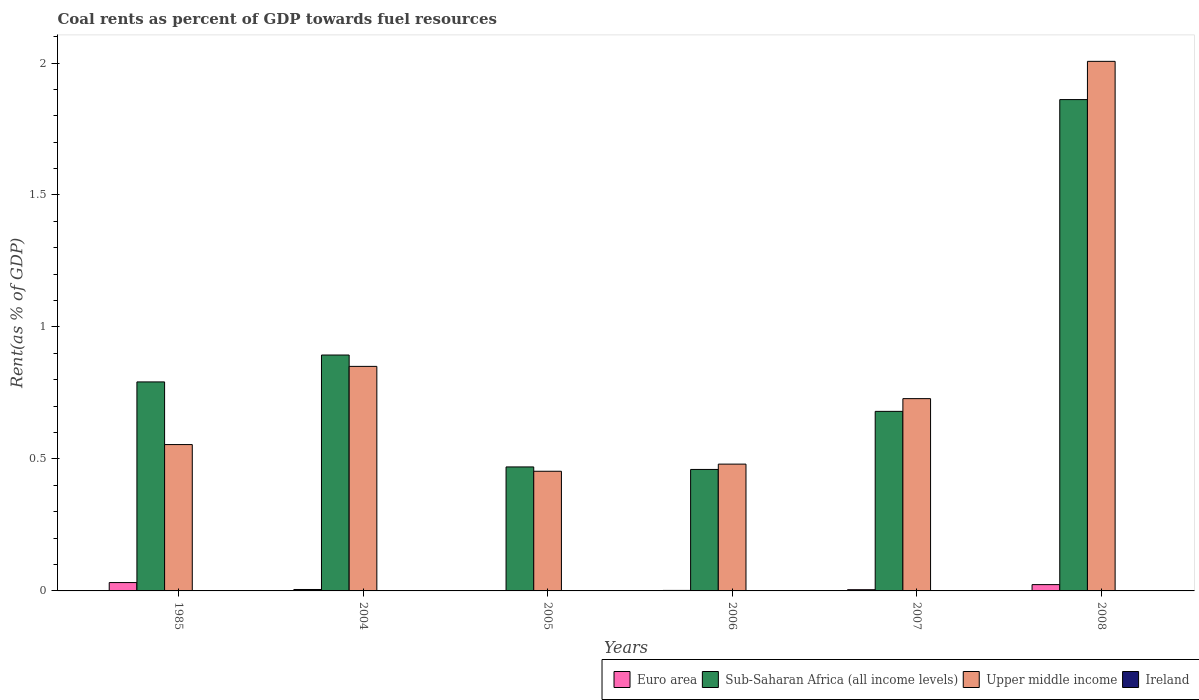Are the number of bars on each tick of the X-axis equal?
Your response must be concise. Yes. What is the label of the 1st group of bars from the left?
Your answer should be compact. 1985. What is the coal rent in Upper middle income in 2006?
Ensure brevity in your answer.  0.48. Across all years, what is the maximum coal rent in Euro area?
Your answer should be compact. 0.03. Across all years, what is the minimum coal rent in Ireland?
Give a very brief answer. 7.66717495498807e-5. In which year was the coal rent in Euro area maximum?
Keep it short and to the point. 1985. In which year was the coal rent in Ireland minimum?
Provide a short and direct response. 2005. What is the total coal rent in Ireland in the graph?
Give a very brief answer. 0. What is the difference between the coal rent in Sub-Saharan Africa (all income levels) in 2005 and that in 2008?
Your response must be concise. -1.39. What is the difference between the coal rent in Ireland in 2005 and the coal rent in Sub-Saharan Africa (all income levels) in 2006?
Ensure brevity in your answer.  -0.46. What is the average coal rent in Euro area per year?
Provide a succinct answer. 0.01. In the year 1985, what is the difference between the coal rent in Ireland and coal rent in Euro area?
Make the answer very short. -0.03. What is the ratio of the coal rent in Euro area in 2007 to that in 2008?
Your response must be concise. 0.2. Is the coal rent in Euro area in 2007 less than that in 2008?
Give a very brief answer. Yes. Is the difference between the coal rent in Ireland in 2004 and 2007 greater than the difference between the coal rent in Euro area in 2004 and 2007?
Your answer should be compact. No. What is the difference between the highest and the second highest coal rent in Sub-Saharan Africa (all income levels)?
Your answer should be compact. 0.97. What is the difference between the highest and the lowest coal rent in Ireland?
Offer a terse response. 0. Is it the case that in every year, the sum of the coal rent in Sub-Saharan Africa (all income levels) and coal rent in Euro area is greater than the sum of coal rent in Upper middle income and coal rent in Ireland?
Offer a very short reply. Yes. What does the 4th bar from the left in 2007 represents?
Ensure brevity in your answer.  Ireland. What does the 2nd bar from the right in 2007 represents?
Provide a succinct answer. Upper middle income. Is it the case that in every year, the sum of the coal rent in Sub-Saharan Africa (all income levels) and coal rent in Ireland is greater than the coal rent in Upper middle income?
Your response must be concise. No. How many bars are there?
Your answer should be compact. 24. Are all the bars in the graph horizontal?
Provide a short and direct response. No. How many years are there in the graph?
Your answer should be very brief. 6. Are the values on the major ticks of Y-axis written in scientific E-notation?
Your answer should be very brief. No. Where does the legend appear in the graph?
Provide a succinct answer. Bottom right. How are the legend labels stacked?
Offer a very short reply. Horizontal. What is the title of the graph?
Offer a very short reply. Coal rents as percent of GDP towards fuel resources. What is the label or title of the Y-axis?
Keep it short and to the point. Rent(as % of GDP). What is the Rent(as % of GDP) of Euro area in 1985?
Your response must be concise. 0.03. What is the Rent(as % of GDP) of Sub-Saharan Africa (all income levels) in 1985?
Offer a very short reply. 0.79. What is the Rent(as % of GDP) in Upper middle income in 1985?
Offer a very short reply. 0.55. What is the Rent(as % of GDP) of Ireland in 1985?
Offer a terse response. 0. What is the Rent(as % of GDP) of Euro area in 2004?
Offer a very short reply. 0.01. What is the Rent(as % of GDP) of Sub-Saharan Africa (all income levels) in 2004?
Your answer should be very brief. 0.89. What is the Rent(as % of GDP) in Upper middle income in 2004?
Keep it short and to the point. 0.85. What is the Rent(as % of GDP) of Ireland in 2004?
Keep it short and to the point. 0. What is the Rent(as % of GDP) in Euro area in 2005?
Your answer should be compact. 0. What is the Rent(as % of GDP) of Sub-Saharan Africa (all income levels) in 2005?
Your answer should be compact. 0.47. What is the Rent(as % of GDP) in Upper middle income in 2005?
Your response must be concise. 0.45. What is the Rent(as % of GDP) in Ireland in 2005?
Offer a terse response. 7.66717495498807e-5. What is the Rent(as % of GDP) in Euro area in 2006?
Give a very brief answer. 0. What is the Rent(as % of GDP) of Sub-Saharan Africa (all income levels) in 2006?
Provide a short and direct response. 0.46. What is the Rent(as % of GDP) in Upper middle income in 2006?
Offer a very short reply. 0.48. What is the Rent(as % of GDP) in Ireland in 2006?
Your response must be concise. 0. What is the Rent(as % of GDP) in Euro area in 2007?
Provide a short and direct response. 0. What is the Rent(as % of GDP) of Sub-Saharan Africa (all income levels) in 2007?
Provide a succinct answer. 0.68. What is the Rent(as % of GDP) in Upper middle income in 2007?
Offer a terse response. 0.73. What is the Rent(as % of GDP) of Ireland in 2007?
Provide a succinct answer. 0. What is the Rent(as % of GDP) of Euro area in 2008?
Provide a succinct answer. 0.02. What is the Rent(as % of GDP) of Sub-Saharan Africa (all income levels) in 2008?
Give a very brief answer. 1.86. What is the Rent(as % of GDP) of Upper middle income in 2008?
Keep it short and to the point. 2.01. What is the Rent(as % of GDP) in Ireland in 2008?
Provide a succinct answer. 0. Across all years, what is the maximum Rent(as % of GDP) of Euro area?
Ensure brevity in your answer.  0.03. Across all years, what is the maximum Rent(as % of GDP) in Sub-Saharan Africa (all income levels)?
Offer a terse response. 1.86. Across all years, what is the maximum Rent(as % of GDP) in Upper middle income?
Provide a succinct answer. 2.01. Across all years, what is the maximum Rent(as % of GDP) of Ireland?
Offer a terse response. 0. Across all years, what is the minimum Rent(as % of GDP) in Euro area?
Make the answer very short. 0. Across all years, what is the minimum Rent(as % of GDP) in Sub-Saharan Africa (all income levels)?
Keep it short and to the point. 0.46. Across all years, what is the minimum Rent(as % of GDP) in Upper middle income?
Keep it short and to the point. 0.45. Across all years, what is the minimum Rent(as % of GDP) of Ireland?
Keep it short and to the point. 7.66717495498807e-5. What is the total Rent(as % of GDP) of Euro area in the graph?
Keep it short and to the point. 0.07. What is the total Rent(as % of GDP) of Sub-Saharan Africa (all income levels) in the graph?
Ensure brevity in your answer.  5.16. What is the total Rent(as % of GDP) of Upper middle income in the graph?
Give a very brief answer. 5.07. What is the total Rent(as % of GDP) in Ireland in the graph?
Your answer should be compact. 0. What is the difference between the Rent(as % of GDP) in Euro area in 1985 and that in 2004?
Your answer should be compact. 0.03. What is the difference between the Rent(as % of GDP) in Sub-Saharan Africa (all income levels) in 1985 and that in 2004?
Your answer should be compact. -0.1. What is the difference between the Rent(as % of GDP) in Upper middle income in 1985 and that in 2004?
Offer a very short reply. -0.3. What is the difference between the Rent(as % of GDP) of Euro area in 1985 and that in 2005?
Your answer should be very brief. 0.03. What is the difference between the Rent(as % of GDP) in Sub-Saharan Africa (all income levels) in 1985 and that in 2005?
Offer a terse response. 0.32. What is the difference between the Rent(as % of GDP) in Upper middle income in 1985 and that in 2005?
Make the answer very short. 0.1. What is the difference between the Rent(as % of GDP) of Ireland in 1985 and that in 2005?
Your answer should be compact. 0. What is the difference between the Rent(as % of GDP) of Euro area in 1985 and that in 2006?
Make the answer very short. 0.03. What is the difference between the Rent(as % of GDP) of Sub-Saharan Africa (all income levels) in 1985 and that in 2006?
Keep it short and to the point. 0.33. What is the difference between the Rent(as % of GDP) of Upper middle income in 1985 and that in 2006?
Your response must be concise. 0.07. What is the difference between the Rent(as % of GDP) in Ireland in 1985 and that in 2006?
Offer a very short reply. 0. What is the difference between the Rent(as % of GDP) in Euro area in 1985 and that in 2007?
Give a very brief answer. 0.03. What is the difference between the Rent(as % of GDP) in Sub-Saharan Africa (all income levels) in 1985 and that in 2007?
Offer a very short reply. 0.11. What is the difference between the Rent(as % of GDP) in Upper middle income in 1985 and that in 2007?
Your response must be concise. -0.17. What is the difference between the Rent(as % of GDP) of Euro area in 1985 and that in 2008?
Your answer should be compact. 0.01. What is the difference between the Rent(as % of GDP) in Sub-Saharan Africa (all income levels) in 1985 and that in 2008?
Provide a short and direct response. -1.07. What is the difference between the Rent(as % of GDP) of Upper middle income in 1985 and that in 2008?
Make the answer very short. -1.45. What is the difference between the Rent(as % of GDP) of Ireland in 1985 and that in 2008?
Your answer should be compact. -0. What is the difference between the Rent(as % of GDP) of Euro area in 2004 and that in 2005?
Your answer should be compact. 0. What is the difference between the Rent(as % of GDP) in Sub-Saharan Africa (all income levels) in 2004 and that in 2005?
Your answer should be compact. 0.42. What is the difference between the Rent(as % of GDP) of Upper middle income in 2004 and that in 2005?
Ensure brevity in your answer.  0.4. What is the difference between the Rent(as % of GDP) of Euro area in 2004 and that in 2006?
Your answer should be compact. 0. What is the difference between the Rent(as % of GDP) in Sub-Saharan Africa (all income levels) in 2004 and that in 2006?
Your answer should be compact. 0.43. What is the difference between the Rent(as % of GDP) of Upper middle income in 2004 and that in 2006?
Offer a very short reply. 0.37. What is the difference between the Rent(as % of GDP) of Ireland in 2004 and that in 2006?
Give a very brief answer. 0. What is the difference between the Rent(as % of GDP) of Euro area in 2004 and that in 2007?
Ensure brevity in your answer.  0. What is the difference between the Rent(as % of GDP) of Sub-Saharan Africa (all income levels) in 2004 and that in 2007?
Provide a succinct answer. 0.21. What is the difference between the Rent(as % of GDP) in Upper middle income in 2004 and that in 2007?
Offer a terse response. 0.12. What is the difference between the Rent(as % of GDP) of Euro area in 2004 and that in 2008?
Give a very brief answer. -0.02. What is the difference between the Rent(as % of GDP) of Sub-Saharan Africa (all income levels) in 2004 and that in 2008?
Your answer should be compact. -0.97. What is the difference between the Rent(as % of GDP) in Upper middle income in 2004 and that in 2008?
Your answer should be very brief. -1.16. What is the difference between the Rent(as % of GDP) in Ireland in 2004 and that in 2008?
Provide a short and direct response. -0. What is the difference between the Rent(as % of GDP) in Euro area in 2005 and that in 2006?
Offer a terse response. -0. What is the difference between the Rent(as % of GDP) in Sub-Saharan Africa (all income levels) in 2005 and that in 2006?
Offer a very short reply. 0.01. What is the difference between the Rent(as % of GDP) in Upper middle income in 2005 and that in 2006?
Your answer should be very brief. -0.03. What is the difference between the Rent(as % of GDP) in Euro area in 2005 and that in 2007?
Ensure brevity in your answer.  -0. What is the difference between the Rent(as % of GDP) of Sub-Saharan Africa (all income levels) in 2005 and that in 2007?
Your answer should be very brief. -0.21. What is the difference between the Rent(as % of GDP) in Upper middle income in 2005 and that in 2007?
Ensure brevity in your answer.  -0.28. What is the difference between the Rent(as % of GDP) in Ireland in 2005 and that in 2007?
Keep it short and to the point. -0. What is the difference between the Rent(as % of GDP) of Euro area in 2005 and that in 2008?
Offer a very short reply. -0.02. What is the difference between the Rent(as % of GDP) of Sub-Saharan Africa (all income levels) in 2005 and that in 2008?
Offer a very short reply. -1.39. What is the difference between the Rent(as % of GDP) in Upper middle income in 2005 and that in 2008?
Provide a succinct answer. -1.55. What is the difference between the Rent(as % of GDP) in Ireland in 2005 and that in 2008?
Ensure brevity in your answer.  -0. What is the difference between the Rent(as % of GDP) in Euro area in 2006 and that in 2007?
Your answer should be compact. -0. What is the difference between the Rent(as % of GDP) in Sub-Saharan Africa (all income levels) in 2006 and that in 2007?
Give a very brief answer. -0.22. What is the difference between the Rent(as % of GDP) of Upper middle income in 2006 and that in 2007?
Your response must be concise. -0.25. What is the difference between the Rent(as % of GDP) of Ireland in 2006 and that in 2007?
Your answer should be very brief. -0. What is the difference between the Rent(as % of GDP) in Euro area in 2006 and that in 2008?
Offer a very short reply. -0.02. What is the difference between the Rent(as % of GDP) in Sub-Saharan Africa (all income levels) in 2006 and that in 2008?
Your answer should be compact. -1.4. What is the difference between the Rent(as % of GDP) in Upper middle income in 2006 and that in 2008?
Your response must be concise. -1.53. What is the difference between the Rent(as % of GDP) in Ireland in 2006 and that in 2008?
Ensure brevity in your answer.  -0. What is the difference between the Rent(as % of GDP) in Euro area in 2007 and that in 2008?
Make the answer very short. -0.02. What is the difference between the Rent(as % of GDP) in Sub-Saharan Africa (all income levels) in 2007 and that in 2008?
Give a very brief answer. -1.18. What is the difference between the Rent(as % of GDP) in Upper middle income in 2007 and that in 2008?
Give a very brief answer. -1.28. What is the difference between the Rent(as % of GDP) in Ireland in 2007 and that in 2008?
Your answer should be very brief. -0. What is the difference between the Rent(as % of GDP) in Euro area in 1985 and the Rent(as % of GDP) in Sub-Saharan Africa (all income levels) in 2004?
Your answer should be very brief. -0.86. What is the difference between the Rent(as % of GDP) in Euro area in 1985 and the Rent(as % of GDP) in Upper middle income in 2004?
Your answer should be very brief. -0.82. What is the difference between the Rent(as % of GDP) in Euro area in 1985 and the Rent(as % of GDP) in Ireland in 2004?
Your answer should be compact. 0.03. What is the difference between the Rent(as % of GDP) in Sub-Saharan Africa (all income levels) in 1985 and the Rent(as % of GDP) in Upper middle income in 2004?
Your answer should be very brief. -0.06. What is the difference between the Rent(as % of GDP) of Sub-Saharan Africa (all income levels) in 1985 and the Rent(as % of GDP) of Ireland in 2004?
Ensure brevity in your answer.  0.79. What is the difference between the Rent(as % of GDP) in Upper middle income in 1985 and the Rent(as % of GDP) in Ireland in 2004?
Your answer should be very brief. 0.55. What is the difference between the Rent(as % of GDP) in Euro area in 1985 and the Rent(as % of GDP) in Sub-Saharan Africa (all income levels) in 2005?
Your answer should be compact. -0.44. What is the difference between the Rent(as % of GDP) of Euro area in 1985 and the Rent(as % of GDP) of Upper middle income in 2005?
Offer a terse response. -0.42. What is the difference between the Rent(as % of GDP) in Euro area in 1985 and the Rent(as % of GDP) in Ireland in 2005?
Offer a very short reply. 0.03. What is the difference between the Rent(as % of GDP) in Sub-Saharan Africa (all income levels) in 1985 and the Rent(as % of GDP) in Upper middle income in 2005?
Your response must be concise. 0.34. What is the difference between the Rent(as % of GDP) of Sub-Saharan Africa (all income levels) in 1985 and the Rent(as % of GDP) of Ireland in 2005?
Provide a succinct answer. 0.79. What is the difference between the Rent(as % of GDP) of Upper middle income in 1985 and the Rent(as % of GDP) of Ireland in 2005?
Make the answer very short. 0.55. What is the difference between the Rent(as % of GDP) of Euro area in 1985 and the Rent(as % of GDP) of Sub-Saharan Africa (all income levels) in 2006?
Keep it short and to the point. -0.43. What is the difference between the Rent(as % of GDP) of Euro area in 1985 and the Rent(as % of GDP) of Upper middle income in 2006?
Ensure brevity in your answer.  -0.45. What is the difference between the Rent(as % of GDP) of Euro area in 1985 and the Rent(as % of GDP) of Ireland in 2006?
Make the answer very short. 0.03. What is the difference between the Rent(as % of GDP) in Sub-Saharan Africa (all income levels) in 1985 and the Rent(as % of GDP) in Upper middle income in 2006?
Your response must be concise. 0.31. What is the difference between the Rent(as % of GDP) in Sub-Saharan Africa (all income levels) in 1985 and the Rent(as % of GDP) in Ireland in 2006?
Offer a terse response. 0.79. What is the difference between the Rent(as % of GDP) in Upper middle income in 1985 and the Rent(as % of GDP) in Ireland in 2006?
Offer a very short reply. 0.55. What is the difference between the Rent(as % of GDP) in Euro area in 1985 and the Rent(as % of GDP) in Sub-Saharan Africa (all income levels) in 2007?
Your answer should be very brief. -0.65. What is the difference between the Rent(as % of GDP) in Euro area in 1985 and the Rent(as % of GDP) in Upper middle income in 2007?
Give a very brief answer. -0.7. What is the difference between the Rent(as % of GDP) of Euro area in 1985 and the Rent(as % of GDP) of Ireland in 2007?
Offer a terse response. 0.03. What is the difference between the Rent(as % of GDP) in Sub-Saharan Africa (all income levels) in 1985 and the Rent(as % of GDP) in Upper middle income in 2007?
Offer a very short reply. 0.06. What is the difference between the Rent(as % of GDP) in Sub-Saharan Africa (all income levels) in 1985 and the Rent(as % of GDP) in Ireland in 2007?
Make the answer very short. 0.79. What is the difference between the Rent(as % of GDP) in Upper middle income in 1985 and the Rent(as % of GDP) in Ireland in 2007?
Give a very brief answer. 0.55. What is the difference between the Rent(as % of GDP) in Euro area in 1985 and the Rent(as % of GDP) in Sub-Saharan Africa (all income levels) in 2008?
Your answer should be very brief. -1.83. What is the difference between the Rent(as % of GDP) in Euro area in 1985 and the Rent(as % of GDP) in Upper middle income in 2008?
Provide a succinct answer. -1.97. What is the difference between the Rent(as % of GDP) in Euro area in 1985 and the Rent(as % of GDP) in Ireland in 2008?
Offer a very short reply. 0.03. What is the difference between the Rent(as % of GDP) of Sub-Saharan Africa (all income levels) in 1985 and the Rent(as % of GDP) of Upper middle income in 2008?
Provide a short and direct response. -1.21. What is the difference between the Rent(as % of GDP) of Sub-Saharan Africa (all income levels) in 1985 and the Rent(as % of GDP) of Ireland in 2008?
Provide a short and direct response. 0.79. What is the difference between the Rent(as % of GDP) of Upper middle income in 1985 and the Rent(as % of GDP) of Ireland in 2008?
Provide a short and direct response. 0.55. What is the difference between the Rent(as % of GDP) of Euro area in 2004 and the Rent(as % of GDP) of Sub-Saharan Africa (all income levels) in 2005?
Provide a succinct answer. -0.46. What is the difference between the Rent(as % of GDP) in Euro area in 2004 and the Rent(as % of GDP) in Upper middle income in 2005?
Offer a terse response. -0.45. What is the difference between the Rent(as % of GDP) in Euro area in 2004 and the Rent(as % of GDP) in Ireland in 2005?
Make the answer very short. 0.01. What is the difference between the Rent(as % of GDP) in Sub-Saharan Africa (all income levels) in 2004 and the Rent(as % of GDP) in Upper middle income in 2005?
Offer a very short reply. 0.44. What is the difference between the Rent(as % of GDP) of Sub-Saharan Africa (all income levels) in 2004 and the Rent(as % of GDP) of Ireland in 2005?
Offer a terse response. 0.89. What is the difference between the Rent(as % of GDP) of Upper middle income in 2004 and the Rent(as % of GDP) of Ireland in 2005?
Your answer should be very brief. 0.85. What is the difference between the Rent(as % of GDP) in Euro area in 2004 and the Rent(as % of GDP) in Sub-Saharan Africa (all income levels) in 2006?
Provide a succinct answer. -0.45. What is the difference between the Rent(as % of GDP) of Euro area in 2004 and the Rent(as % of GDP) of Upper middle income in 2006?
Your answer should be very brief. -0.47. What is the difference between the Rent(as % of GDP) in Euro area in 2004 and the Rent(as % of GDP) in Ireland in 2006?
Your answer should be very brief. 0.01. What is the difference between the Rent(as % of GDP) in Sub-Saharan Africa (all income levels) in 2004 and the Rent(as % of GDP) in Upper middle income in 2006?
Your response must be concise. 0.41. What is the difference between the Rent(as % of GDP) of Sub-Saharan Africa (all income levels) in 2004 and the Rent(as % of GDP) of Ireland in 2006?
Provide a short and direct response. 0.89. What is the difference between the Rent(as % of GDP) in Upper middle income in 2004 and the Rent(as % of GDP) in Ireland in 2006?
Your answer should be compact. 0.85. What is the difference between the Rent(as % of GDP) in Euro area in 2004 and the Rent(as % of GDP) in Sub-Saharan Africa (all income levels) in 2007?
Your answer should be compact. -0.67. What is the difference between the Rent(as % of GDP) of Euro area in 2004 and the Rent(as % of GDP) of Upper middle income in 2007?
Your answer should be compact. -0.72. What is the difference between the Rent(as % of GDP) in Euro area in 2004 and the Rent(as % of GDP) in Ireland in 2007?
Your response must be concise. 0.01. What is the difference between the Rent(as % of GDP) in Sub-Saharan Africa (all income levels) in 2004 and the Rent(as % of GDP) in Upper middle income in 2007?
Provide a short and direct response. 0.17. What is the difference between the Rent(as % of GDP) of Sub-Saharan Africa (all income levels) in 2004 and the Rent(as % of GDP) of Ireland in 2007?
Your answer should be compact. 0.89. What is the difference between the Rent(as % of GDP) in Upper middle income in 2004 and the Rent(as % of GDP) in Ireland in 2007?
Your answer should be compact. 0.85. What is the difference between the Rent(as % of GDP) of Euro area in 2004 and the Rent(as % of GDP) of Sub-Saharan Africa (all income levels) in 2008?
Your answer should be very brief. -1.86. What is the difference between the Rent(as % of GDP) in Euro area in 2004 and the Rent(as % of GDP) in Upper middle income in 2008?
Give a very brief answer. -2. What is the difference between the Rent(as % of GDP) of Euro area in 2004 and the Rent(as % of GDP) of Ireland in 2008?
Offer a terse response. 0. What is the difference between the Rent(as % of GDP) in Sub-Saharan Africa (all income levels) in 2004 and the Rent(as % of GDP) in Upper middle income in 2008?
Your answer should be compact. -1.11. What is the difference between the Rent(as % of GDP) of Sub-Saharan Africa (all income levels) in 2004 and the Rent(as % of GDP) of Ireland in 2008?
Offer a very short reply. 0.89. What is the difference between the Rent(as % of GDP) of Upper middle income in 2004 and the Rent(as % of GDP) of Ireland in 2008?
Give a very brief answer. 0.85. What is the difference between the Rent(as % of GDP) of Euro area in 2005 and the Rent(as % of GDP) of Sub-Saharan Africa (all income levels) in 2006?
Provide a short and direct response. -0.46. What is the difference between the Rent(as % of GDP) of Euro area in 2005 and the Rent(as % of GDP) of Upper middle income in 2006?
Make the answer very short. -0.48. What is the difference between the Rent(as % of GDP) of Euro area in 2005 and the Rent(as % of GDP) of Ireland in 2006?
Provide a succinct answer. 0. What is the difference between the Rent(as % of GDP) of Sub-Saharan Africa (all income levels) in 2005 and the Rent(as % of GDP) of Upper middle income in 2006?
Provide a short and direct response. -0.01. What is the difference between the Rent(as % of GDP) in Sub-Saharan Africa (all income levels) in 2005 and the Rent(as % of GDP) in Ireland in 2006?
Your answer should be very brief. 0.47. What is the difference between the Rent(as % of GDP) of Upper middle income in 2005 and the Rent(as % of GDP) of Ireland in 2006?
Offer a terse response. 0.45. What is the difference between the Rent(as % of GDP) in Euro area in 2005 and the Rent(as % of GDP) in Sub-Saharan Africa (all income levels) in 2007?
Ensure brevity in your answer.  -0.68. What is the difference between the Rent(as % of GDP) in Euro area in 2005 and the Rent(as % of GDP) in Upper middle income in 2007?
Provide a succinct answer. -0.73. What is the difference between the Rent(as % of GDP) in Euro area in 2005 and the Rent(as % of GDP) in Ireland in 2007?
Your response must be concise. 0. What is the difference between the Rent(as % of GDP) in Sub-Saharan Africa (all income levels) in 2005 and the Rent(as % of GDP) in Upper middle income in 2007?
Your answer should be very brief. -0.26. What is the difference between the Rent(as % of GDP) of Sub-Saharan Africa (all income levels) in 2005 and the Rent(as % of GDP) of Ireland in 2007?
Make the answer very short. 0.47. What is the difference between the Rent(as % of GDP) of Upper middle income in 2005 and the Rent(as % of GDP) of Ireland in 2007?
Your answer should be very brief. 0.45. What is the difference between the Rent(as % of GDP) of Euro area in 2005 and the Rent(as % of GDP) of Sub-Saharan Africa (all income levels) in 2008?
Provide a succinct answer. -1.86. What is the difference between the Rent(as % of GDP) of Euro area in 2005 and the Rent(as % of GDP) of Upper middle income in 2008?
Provide a succinct answer. -2. What is the difference between the Rent(as % of GDP) in Sub-Saharan Africa (all income levels) in 2005 and the Rent(as % of GDP) in Upper middle income in 2008?
Your answer should be compact. -1.54. What is the difference between the Rent(as % of GDP) in Sub-Saharan Africa (all income levels) in 2005 and the Rent(as % of GDP) in Ireland in 2008?
Your answer should be very brief. 0.47. What is the difference between the Rent(as % of GDP) in Upper middle income in 2005 and the Rent(as % of GDP) in Ireland in 2008?
Offer a very short reply. 0.45. What is the difference between the Rent(as % of GDP) of Euro area in 2006 and the Rent(as % of GDP) of Sub-Saharan Africa (all income levels) in 2007?
Your response must be concise. -0.68. What is the difference between the Rent(as % of GDP) of Euro area in 2006 and the Rent(as % of GDP) of Upper middle income in 2007?
Offer a very short reply. -0.73. What is the difference between the Rent(as % of GDP) of Euro area in 2006 and the Rent(as % of GDP) of Ireland in 2007?
Offer a very short reply. 0. What is the difference between the Rent(as % of GDP) in Sub-Saharan Africa (all income levels) in 2006 and the Rent(as % of GDP) in Upper middle income in 2007?
Keep it short and to the point. -0.27. What is the difference between the Rent(as % of GDP) in Sub-Saharan Africa (all income levels) in 2006 and the Rent(as % of GDP) in Ireland in 2007?
Provide a succinct answer. 0.46. What is the difference between the Rent(as % of GDP) in Upper middle income in 2006 and the Rent(as % of GDP) in Ireland in 2007?
Ensure brevity in your answer.  0.48. What is the difference between the Rent(as % of GDP) of Euro area in 2006 and the Rent(as % of GDP) of Sub-Saharan Africa (all income levels) in 2008?
Offer a very short reply. -1.86. What is the difference between the Rent(as % of GDP) of Euro area in 2006 and the Rent(as % of GDP) of Upper middle income in 2008?
Offer a terse response. -2. What is the difference between the Rent(as % of GDP) in Sub-Saharan Africa (all income levels) in 2006 and the Rent(as % of GDP) in Upper middle income in 2008?
Offer a terse response. -1.55. What is the difference between the Rent(as % of GDP) of Sub-Saharan Africa (all income levels) in 2006 and the Rent(as % of GDP) of Ireland in 2008?
Keep it short and to the point. 0.46. What is the difference between the Rent(as % of GDP) in Upper middle income in 2006 and the Rent(as % of GDP) in Ireland in 2008?
Provide a short and direct response. 0.48. What is the difference between the Rent(as % of GDP) of Euro area in 2007 and the Rent(as % of GDP) of Sub-Saharan Africa (all income levels) in 2008?
Provide a succinct answer. -1.86. What is the difference between the Rent(as % of GDP) of Euro area in 2007 and the Rent(as % of GDP) of Upper middle income in 2008?
Keep it short and to the point. -2. What is the difference between the Rent(as % of GDP) in Euro area in 2007 and the Rent(as % of GDP) in Ireland in 2008?
Provide a succinct answer. 0. What is the difference between the Rent(as % of GDP) in Sub-Saharan Africa (all income levels) in 2007 and the Rent(as % of GDP) in Upper middle income in 2008?
Your answer should be very brief. -1.33. What is the difference between the Rent(as % of GDP) in Sub-Saharan Africa (all income levels) in 2007 and the Rent(as % of GDP) in Ireland in 2008?
Provide a short and direct response. 0.68. What is the difference between the Rent(as % of GDP) of Upper middle income in 2007 and the Rent(as % of GDP) of Ireland in 2008?
Make the answer very short. 0.73. What is the average Rent(as % of GDP) of Euro area per year?
Ensure brevity in your answer.  0.01. What is the average Rent(as % of GDP) of Sub-Saharan Africa (all income levels) per year?
Give a very brief answer. 0.86. What is the average Rent(as % of GDP) in Upper middle income per year?
Your answer should be compact. 0.85. In the year 1985, what is the difference between the Rent(as % of GDP) of Euro area and Rent(as % of GDP) of Sub-Saharan Africa (all income levels)?
Offer a very short reply. -0.76. In the year 1985, what is the difference between the Rent(as % of GDP) in Euro area and Rent(as % of GDP) in Upper middle income?
Your answer should be compact. -0.52. In the year 1985, what is the difference between the Rent(as % of GDP) in Euro area and Rent(as % of GDP) in Ireland?
Make the answer very short. 0.03. In the year 1985, what is the difference between the Rent(as % of GDP) in Sub-Saharan Africa (all income levels) and Rent(as % of GDP) in Upper middle income?
Provide a short and direct response. 0.24. In the year 1985, what is the difference between the Rent(as % of GDP) of Sub-Saharan Africa (all income levels) and Rent(as % of GDP) of Ireland?
Keep it short and to the point. 0.79. In the year 1985, what is the difference between the Rent(as % of GDP) in Upper middle income and Rent(as % of GDP) in Ireland?
Provide a short and direct response. 0.55. In the year 2004, what is the difference between the Rent(as % of GDP) of Euro area and Rent(as % of GDP) of Sub-Saharan Africa (all income levels)?
Provide a succinct answer. -0.89. In the year 2004, what is the difference between the Rent(as % of GDP) in Euro area and Rent(as % of GDP) in Upper middle income?
Your answer should be very brief. -0.85. In the year 2004, what is the difference between the Rent(as % of GDP) in Euro area and Rent(as % of GDP) in Ireland?
Give a very brief answer. 0.01. In the year 2004, what is the difference between the Rent(as % of GDP) in Sub-Saharan Africa (all income levels) and Rent(as % of GDP) in Upper middle income?
Provide a succinct answer. 0.04. In the year 2004, what is the difference between the Rent(as % of GDP) in Sub-Saharan Africa (all income levels) and Rent(as % of GDP) in Ireland?
Provide a short and direct response. 0.89. In the year 2004, what is the difference between the Rent(as % of GDP) in Upper middle income and Rent(as % of GDP) in Ireland?
Provide a succinct answer. 0.85. In the year 2005, what is the difference between the Rent(as % of GDP) in Euro area and Rent(as % of GDP) in Sub-Saharan Africa (all income levels)?
Make the answer very short. -0.47. In the year 2005, what is the difference between the Rent(as % of GDP) of Euro area and Rent(as % of GDP) of Upper middle income?
Offer a very short reply. -0.45. In the year 2005, what is the difference between the Rent(as % of GDP) of Euro area and Rent(as % of GDP) of Ireland?
Provide a short and direct response. 0. In the year 2005, what is the difference between the Rent(as % of GDP) in Sub-Saharan Africa (all income levels) and Rent(as % of GDP) in Upper middle income?
Ensure brevity in your answer.  0.02. In the year 2005, what is the difference between the Rent(as % of GDP) of Sub-Saharan Africa (all income levels) and Rent(as % of GDP) of Ireland?
Your answer should be compact. 0.47. In the year 2005, what is the difference between the Rent(as % of GDP) in Upper middle income and Rent(as % of GDP) in Ireland?
Your answer should be compact. 0.45. In the year 2006, what is the difference between the Rent(as % of GDP) in Euro area and Rent(as % of GDP) in Sub-Saharan Africa (all income levels)?
Give a very brief answer. -0.46. In the year 2006, what is the difference between the Rent(as % of GDP) in Euro area and Rent(as % of GDP) in Upper middle income?
Your answer should be compact. -0.48. In the year 2006, what is the difference between the Rent(as % of GDP) of Euro area and Rent(as % of GDP) of Ireland?
Give a very brief answer. 0. In the year 2006, what is the difference between the Rent(as % of GDP) in Sub-Saharan Africa (all income levels) and Rent(as % of GDP) in Upper middle income?
Give a very brief answer. -0.02. In the year 2006, what is the difference between the Rent(as % of GDP) of Sub-Saharan Africa (all income levels) and Rent(as % of GDP) of Ireland?
Make the answer very short. 0.46. In the year 2006, what is the difference between the Rent(as % of GDP) in Upper middle income and Rent(as % of GDP) in Ireland?
Provide a short and direct response. 0.48. In the year 2007, what is the difference between the Rent(as % of GDP) in Euro area and Rent(as % of GDP) in Sub-Saharan Africa (all income levels)?
Offer a very short reply. -0.68. In the year 2007, what is the difference between the Rent(as % of GDP) in Euro area and Rent(as % of GDP) in Upper middle income?
Offer a terse response. -0.72. In the year 2007, what is the difference between the Rent(as % of GDP) in Euro area and Rent(as % of GDP) in Ireland?
Provide a succinct answer. 0. In the year 2007, what is the difference between the Rent(as % of GDP) in Sub-Saharan Africa (all income levels) and Rent(as % of GDP) in Upper middle income?
Your response must be concise. -0.05. In the year 2007, what is the difference between the Rent(as % of GDP) of Sub-Saharan Africa (all income levels) and Rent(as % of GDP) of Ireland?
Make the answer very short. 0.68. In the year 2007, what is the difference between the Rent(as % of GDP) of Upper middle income and Rent(as % of GDP) of Ireland?
Your answer should be compact. 0.73. In the year 2008, what is the difference between the Rent(as % of GDP) in Euro area and Rent(as % of GDP) in Sub-Saharan Africa (all income levels)?
Provide a succinct answer. -1.84. In the year 2008, what is the difference between the Rent(as % of GDP) in Euro area and Rent(as % of GDP) in Upper middle income?
Provide a succinct answer. -1.98. In the year 2008, what is the difference between the Rent(as % of GDP) of Euro area and Rent(as % of GDP) of Ireland?
Keep it short and to the point. 0.02. In the year 2008, what is the difference between the Rent(as % of GDP) of Sub-Saharan Africa (all income levels) and Rent(as % of GDP) of Upper middle income?
Your answer should be compact. -0.14. In the year 2008, what is the difference between the Rent(as % of GDP) in Sub-Saharan Africa (all income levels) and Rent(as % of GDP) in Ireland?
Your answer should be compact. 1.86. In the year 2008, what is the difference between the Rent(as % of GDP) in Upper middle income and Rent(as % of GDP) in Ireland?
Make the answer very short. 2. What is the ratio of the Rent(as % of GDP) of Euro area in 1985 to that in 2004?
Offer a very short reply. 5.82. What is the ratio of the Rent(as % of GDP) of Sub-Saharan Africa (all income levels) in 1985 to that in 2004?
Offer a very short reply. 0.89. What is the ratio of the Rent(as % of GDP) in Upper middle income in 1985 to that in 2004?
Provide a short and direct response. 0.65. What is the ratio of the Rent(as % of GDP) in Ireland in 1985 to that in 2004?
Keep it short and to the point. 2.21. What is the ratio of the Rent(as % of GDP) of Euro area in 1985 to that in 2005?
Provide a short and direct response. 20.02. What is the ratio of the Rent(as % of GDP) of Sub-Saharan Africa (all income levels) in 1985 to that in 2005?
Provide a short and direct response. 1.69. What is the ratio of the Rent(as % of GDP) of Upper middle income in 1985 to that in 2005?
Your answer should be compact. 1.22. What is the ratio of the Rent(as % of GDP) of Ireland in 1985 to that in 2005?
Make the answer very short. 9.93. What is the ratio of the Rent(as % of GDP) in Euro area in 1985 to that in 2006?
Offer a terse response. 16.38. What is the ratio of the Rent(as % of GDP) in Sub-Saharan Africa (all income levels) in 1985 to that in 2006?
Offer a terse response. 1.72. What is the ratio of the Rent(as % of GDP) of Upper middle income in 1985 to that in 2006?
Give a very brief answer. 1.15. What is the ratio of the Rent(as % of GDP) of Ireland in 1985 to that in 2006?
Provide a short and direct response. 6.67. What is the ratio of the Rent(as % of GDP) in Euro area in 1985 to that in 2007?
Your response must be concise. 6.78. What is the ratio of the Rent(as % of GDP) in Sub-Saharan Africa (all income levels) in 1985 to that in 2007?
Offer a terse response. 1.16. What is the ratio of the Rent(as % of GDP) in Upper middle income in 1985 to that in 2007?
Your response must be concise. 0.76. What is the ratio of the Rent(as % of GDP) in Ireland in 1985 to that in 2007?
Make the answer very short. 2.49. What is the ratio of the Rent(as % of GDP) of Euro area in 1985 to that in 2008?
Provide a succinct answer. 1.33. What is the ratio of the Rent(as % of GDP) of Sub-Saharan Africa (all income levels) in 1985 to that in 2008?
Your answer should be compact. 0.43. What is the ratio of the Rent(as % of GDP) in Upper middle income in 1985 to that in 2008?
Your answer should be very brief. 0.28. What is the ratio of the Rent(as % of GDP) in Ireland in 1985 to that in 2008?
Provide a succinct answer. 0.5. What is the ratio of the Rent(as % of GDP) of Euro area in 2004 to that in 2005?
Give a very brief answer. 3.44. What is the ratio of the Rent(as % of GDP) in Sub-Saharan Africa (all income levels) in 2004 to that in 2005?
Offer a terse response. 1.9. What is the ratio of the Rent(as % of GDP) in Upper middle income in 2004 to that in 2005?
Your answer should be compact. 1.88. What is the ratio of the Rent(as % of GDP) of Ireland in 2004 to that in 2005?
Offer a terse response. 4.49. What is the ratio of the Rent(as % of GDP) of Euro area in 2004 to that in 2006?
Offer a terse response. 2.81. What is the ratio of the Rent(as % of GDP) in Sub-Saharan Africa (all income levels) in 2004 to that in 2006?
Offer a terse response. 1.94. What is the ratio of the Rent(as % of GDP) in Upper middle income in 2004 to that in 2006?
Ensure brevity in your answer.  1.77. What is the ratio of the Rent(as % of GDP) in Ireland in 2004 to that in 2006?
Offer a very short reply. 3.01. What is the ratio of the Rent(as % of GDP) of Euro area in 2004 to that in 2007?
Offer a terse response. 1.16. What is the ratio of the Rent(as % of GDP) of Sub-Saharan Africa (all income levels) in 2004 to that in 2007?
Provide a short and direct response. 1.31. What is the ratio of the Rent(as % of GDP) in Upper middle income in 2004 to that in 2007?
Give a very brief answer. 1.17. What is the ratio of the Rent(as % of GDP) of Ireland in 2004 to that in 2007?
Ensure brevity in your answer.  1.12. What is the ratio of the Rent(as % of GDP) of Euro area in 2004 to that in 2008?
Your response must be concise. 0.23. What is the ratio of the Rent(as % of GDP) of Sub-Saharan Africa (all income levels) in 2004 to that in 2008?
Provide a short and direct response. 0.48. What is the ratio of the Rent(as % of GDP) of Upper middle income in 2004 to that in 2008?
Make the answer very short. 0.42. What is the ratio of the Rent(as % of GDP) of Ireland in 2004 to that in 2008?
Keep it short and to the point. 0.23. What is the ratio of the Rent(as % of GDP) of Euro area in 2005 to that in 2006?
Give a very brief answer. 0.82. What is the ratio of the Rent(as % of GDP) in Sub-Saharan Africa (all income levels) in 2005 to that in 2006?
Offer a terse response. 1.02. What is the ratio of the Rent(as % of GDP) in Upper middle income in 2005 to that in 2006?
Your answer should be very brief. 0.94. What is the ratio of the Rent(as % of GDP) of Ireland in 2005 to that in 2006?
Your answer should be compact. 0.67. What is the ratio of the Rent(as % of GDP) of Euro area in 2005 to that in 2007?
Your response must be concise. 0.34. What is the ratio of the Rent(as % of GDP) of Sub-Saharan Africa (all income levels) in 2005 to that in 2007?
Keep it short and to the point. 0.69. What is the ratio of the Rent(as % of GDP) in Upper middle income in 2005 to that in 2007?
Make the answer very short. 0.62. What is the ratio of the Rent(as % of GDP) in Ireland in 2005 to that in 2007?
Make the answer very short. 0.25. What is the ratio of the Rent(as % of GDP) of Euro area in 2005 to that in 2008?
Your answer should be compact. 0.07. What is the ratio of the Rent(as % of GDP) of Sub-Saharan Africa (all income levels) in 2005 to that in 2008?
Your response must be concise. 0.25. What is the ratio of the Rent(as % of GDP) in Upper middle income in 2005 to that in 2008?
Make the answer very short. 0.23. What is the ratio of the Rent(as % of GDP) in Ireland in 2005 to that in 2008?
Offer a terse response. 0.05. What is the ratio of the Rent(as % of GDP) in Euro area in 2006 to that in 2007?
Your answer should be compact. 0.41. What is the ratio of the Rent(as % of GDP) of Sub-Saharan Africa (all income levels) in 2006 to that in 2007?
Ensure brevity in your answer.  0.68. What is the ratio of the Rent(as % of GDP) of Upper middle income in 2006 to that in 2007?
Make the answer very short. 0.66. What is the ratio of the Rent(as % of GDP) of Ireland in 2006 to that in 2007?
Your answer should be compact. 0.37. What is the ratio of the Rent(as % of GDP) in Euro area in 2006 to that in 2008?
Provide a short and direct response. 0.08. What is the ratio of the Rent(as % of GDP) in Sub-Saharan Africa (all income levels) in 2006 to that in 2008?
Provide a succinct answer. 0.25. What is the ratio of the Rent(as % of GDP) in Upper middle income in 2006 to that in 2008?
Provide a succinct answer. 0.24. What is the ratio of the Rent(as % of GDP) of Ireland in 2006 to that in 2008?
Your answer should be very brief. 0.07. What is the ratio of the Rent(as % of GDP) in Euro area in 2007 to that in 2008?
Offer a very short reply. 0.2. What is the ratio of the Rent(as % of GDP) in Sub-Saharan Africa (all income levels) in 2007 to that in 2008?
Provide a short and direct response. 0.37. What is the ratio of the Rent(as % of GDP) of Upper middle income in 2007 to that in 2008?
Ensure brevity in your answer.  0.36. What is the ratio of the Rent(as % of GDP) of Ireland in 2007 to that in 2008?
Give a very brief answer. 0.2. What is the difference between the highest and the second highest Rent(as % of GDP) of Euro area?
Your response must be concise. 0.01. What is the difference between the highest and the second highest Rent(as % of GDP) of Sub-Saharan Africa (all income levels)?
Provide a short and direct response. 0.97. What is the difference between the highest and the second highest Rent(as % of GDP) in Upper middle income?
Provide a short and direct response. 1.16. What is the difference between the highest and the second highest Rent(as % of GDP) of Ireland?
Offer a terse response. 0. What is the difference between the highest and the lowest Rent(as % of GDP) of Euro area?
Make the answer very short. 0.03. What is the difference between the highest and the lowest Rent(as % of GDP) of Sub-Saharan Africa (all income levels)?
Provide a succinct answer. 1.4. What is the difference between the highest and the lowest Rent(as % of GDP) in Upper middle income?
Provide a succinct answer. 1.55. What is the difference between the highest and the lowest Rent(as % of GDP) in Ireland?
Your response must be concise. 0. 